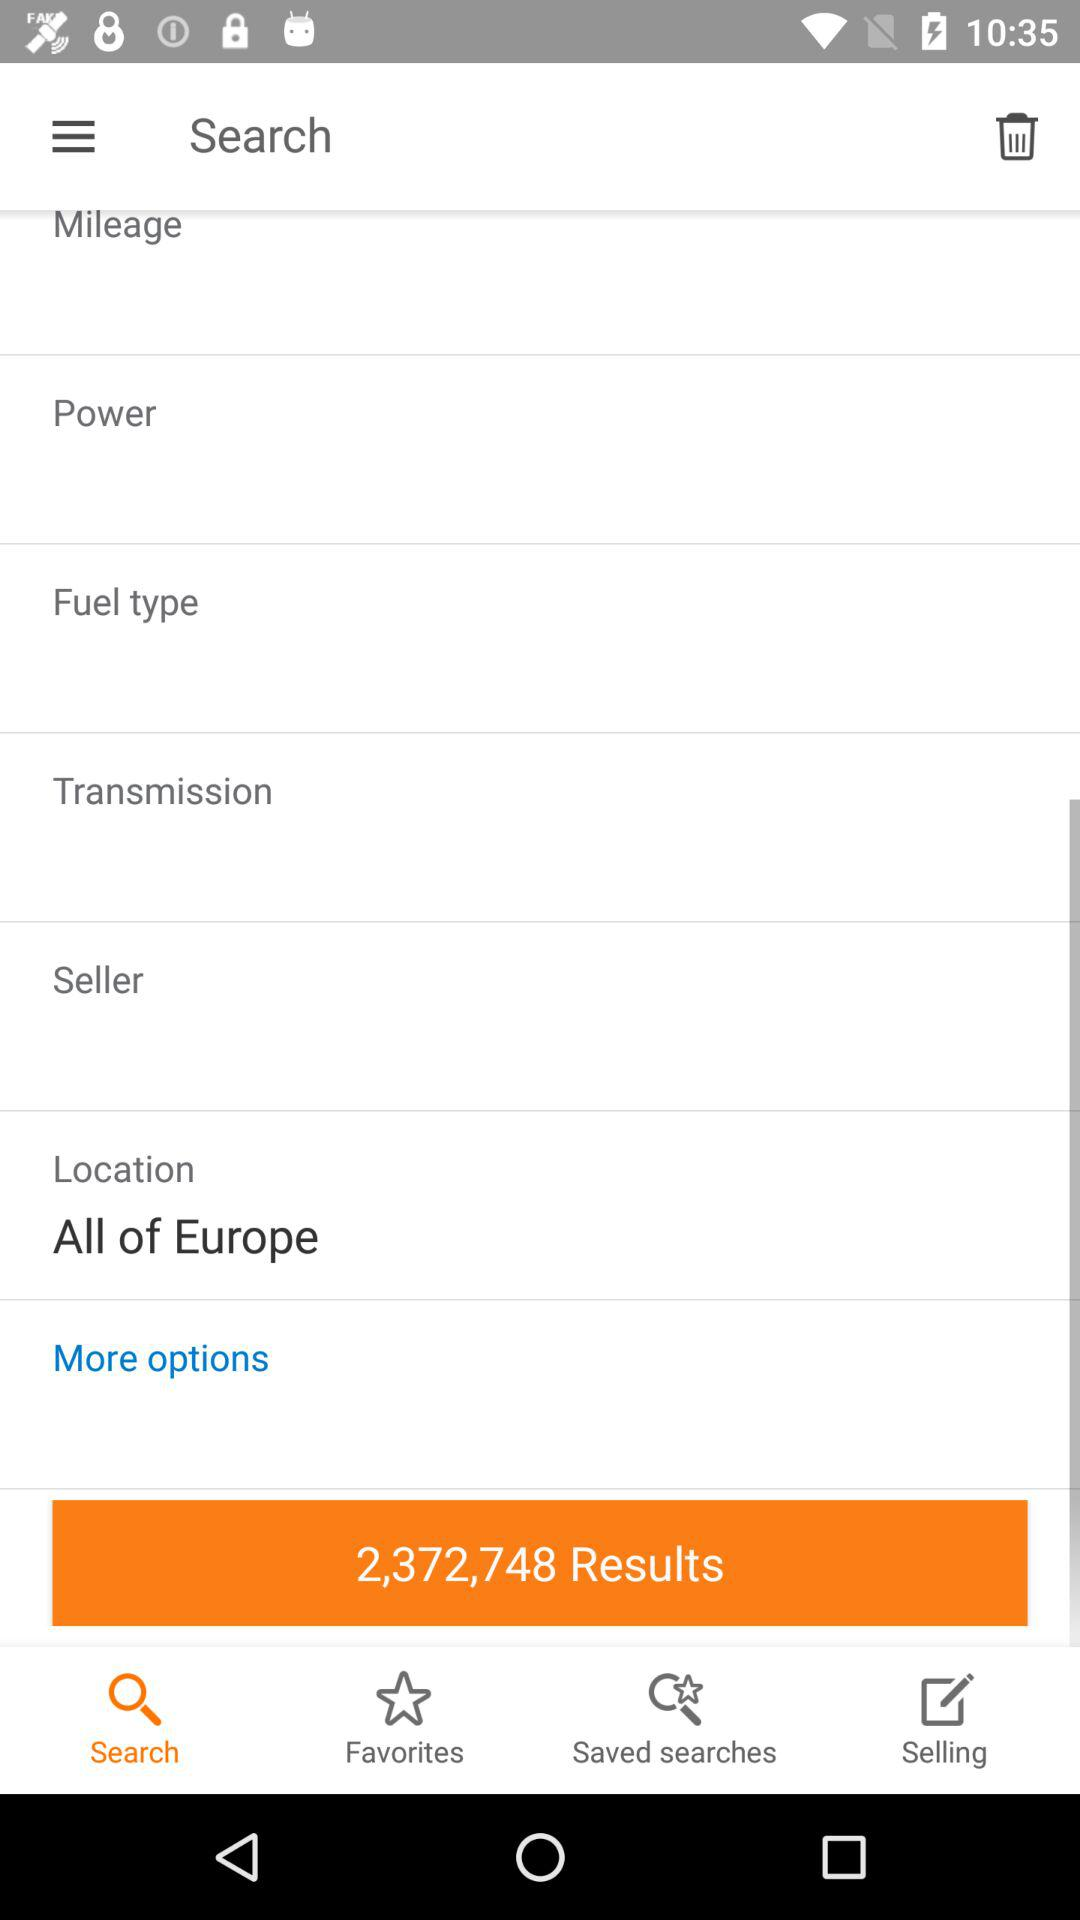What is the location? The location is "All of Europe". 